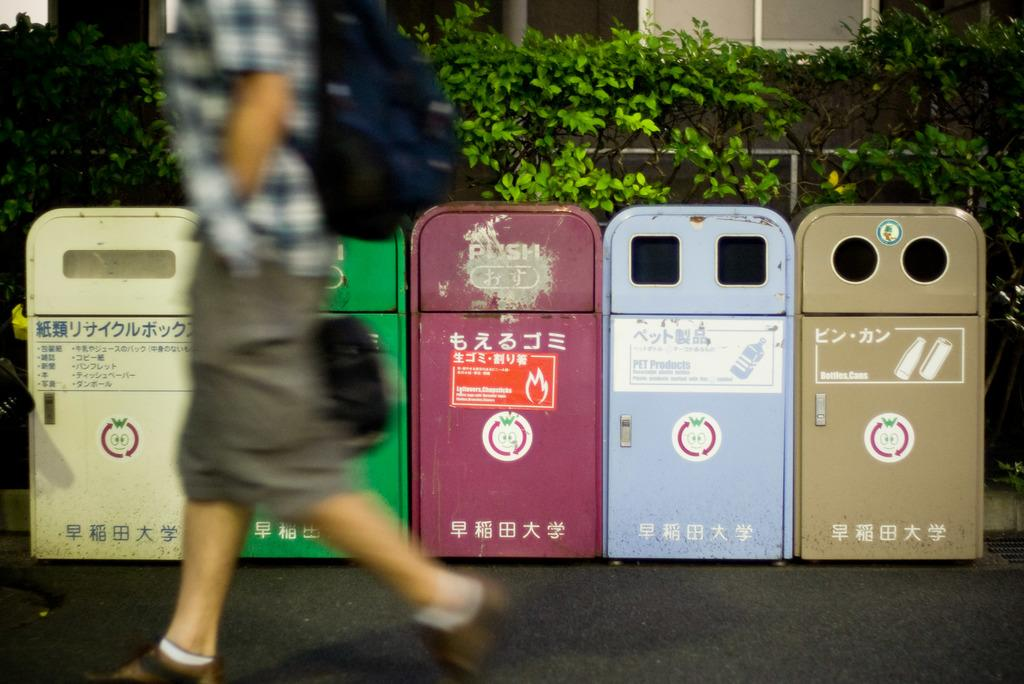<image>
Relay a brief, clear account of the picture shown. five separate trash bins with one of them labeled with 'pet products' 